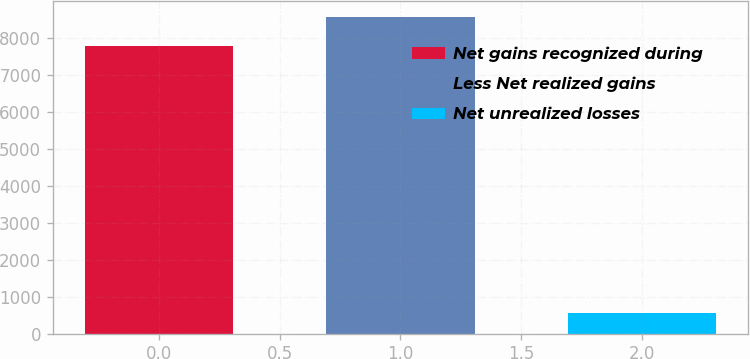Convert chart. <chart><loc_0><loc_0><loc_500><loc_500><bar_chart><fcel>Net gains recognized during<fcel>Less Net realized gains<fcel>Net unrealized losses<nl><fcel>7785<fcel>8563.5<fcel>546<nl></chart> 